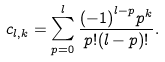<formula> <loc_0><loc_0><loc_500><loc_500>c _ { l , k } = \sum _ { p = 0 } ^ { l } \frac { { ( - 1 ) } ^ { l - p } p ^ { k } } { p ! ( l - p ) ! } .</formula> 